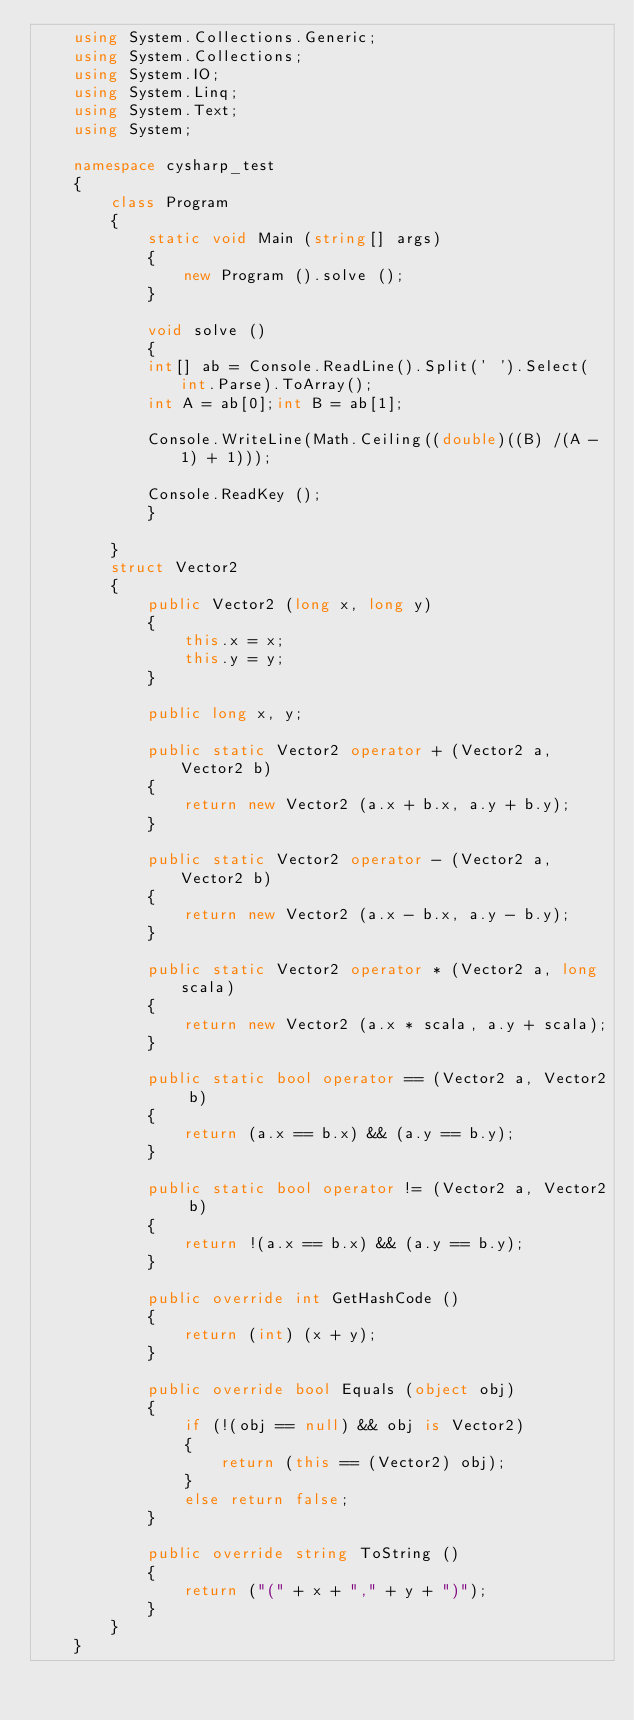Convert code to text. <code><loc_0><loc_0><loc_500><loc_500><_C#_>    using System.Collections.Generic;
    using System.Collections;
    using System.IO;
    using System.Linq;
    using System.Text;
    using System;

    namespace cysharp_test
    {
        class Program
        {
            static void Main (string[] args)
            {
                new Program ().solve ();
            }

            void solve ()
            {
            int[] ab = Console.ReadLine().Split(' ').Select(int.Parse).ToArray();
            int A = ab[0];int B = ab[1];

            Console.WriteLine(Math.Ceiling((double)((B) /(A - 1) + 1)));

            Console.ReadKey ();
            }

        }
        struct Vector2
        {
            public Vector2 (long x, long y)
            {
                this.x = x;
                this.y = y;
            }

            public long x, y;

            public static Vector2 operator + (Vector2 a, Vector2 b)
            {
                return new Vector2 (a.x + b.x, a.y + b.y);
            }

            public static Vector2 operator - (Vector2 a, Vector2 b)
            {
                return new Vector2 (a.x - b.x, a.y - b.y);
            }

            public static Vector2 operator * (Vector2 a, long scala)
            {
                return new Vector2 (a.x * scala, a.y + scala);
            }

            public static bool operator == (Vector2 a, Vector2 b)
            {
                return (a.x == b.x) && (a.y == b.y);
            }

            public static bool operator != (Vector2 a, Vector2 b)
            {
                return !(a.x == b.x) && (a.y == b.y);
            }

            public override int GetHashCode ()
            {
                return (int) (x + y);
            }

            public override bool Equals (object obj)
            {
                if (!(obj == null) && obj is Vector2)
                {
                    return (this == (Vector2) obj);
                }
                else return false;
            }

            public override string ToString ()
            {
                return ("(" + x + "," + y + ")");
            }
        }
    }</code> 